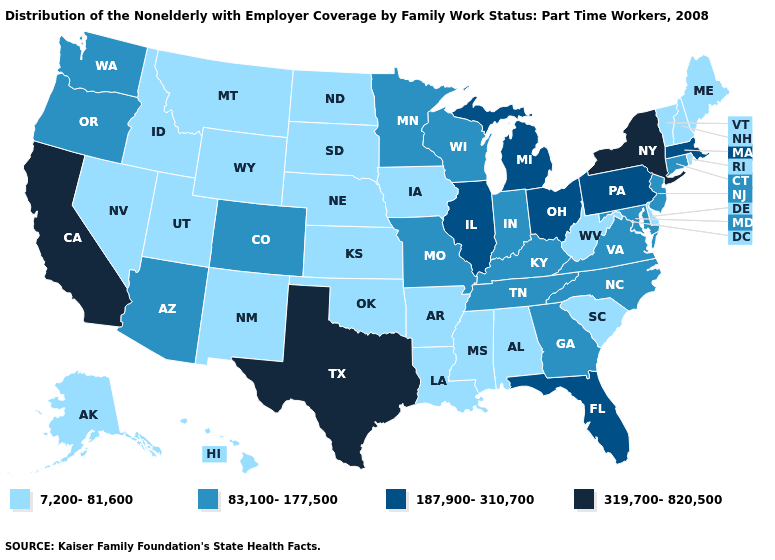Name the states that have a value in the range 83,100-177,500?
Keep it brief. Arizona, Colorado, Connecticut, Georgia, Indiana, Kentucky, Maryland, Minnesota, Missouri, New Jersey, North Carolina, Oregon, Tennessee, Virginia, Washington, Wisconsin. What is the lowest value in the USA?
Answer briefly. 7,200-81,600. What is the lowest value in the South?
Answer briefly. 7,200-81,600. Name the states that have a value in the range 7,200-81,600?
Quick response, please. Alabama, Alaska, Arkansas, Delaware, Hawaii, Idaho, Iowa, Kansas, Louisiana, Maine, Mississippi, Montana, Nebraska, Nevada, New Hampshire, New Mexico, North Dakota, Oklahoma, Rhode Island, South Carolina, South Dakota, Utah, Vermont, West Virginia, Wyoming. Which states have the lowest value in the MidWest?
Give a very brief answer. Iowa, Kansas, Nebraska, North Dakota, South Dakota. What is the highest value in the MidWest ?
Answer briefly. 187,900-310,700. Name the states that have a value in the range 319,700-820,500?
Be succinct. California, New York, Texas. Name the states that have a value in the range 7,200-81,600?
Write a very short answer. Alabama, Alaska, Arkansas, Delaware, Hawaii, Idaho, Iowa, Kansas, Louisiana, Maine, Mississippi, Montana, Nebraska, Nevada, New Hampshire, New Mexico, North Dakota, Oklahoma, Rhode Island, South Carolina, South Dakota, Utah, Vermont, West Virginia, Wyoming. Does Nevada have the highest value in the USA?
Keep it brief. No. Name the states that have a value in the range 187,900-310,700?
Be succinct. Florida, Illinois, Massachusetts, Michigan, Ohio, Pennsylvania. Name the states that have a value in the range 187,900-310,700?
Short answer required. Florida, Illinois, Massachusetts, Michigan, Ohio, Pennsylvania. What is the value of Montana?
Write a very short answer. 7,200-81,600. Which states have the lowest value in the MidWest?
Write a very short answer. Iowa, Kansas, Nebraska, North Dakota, South Dakota. Is the legend a continuous bar?
Give a very brief answer. No. What is the lowest value in the South?
Be succinct. 7,200-81,600. 